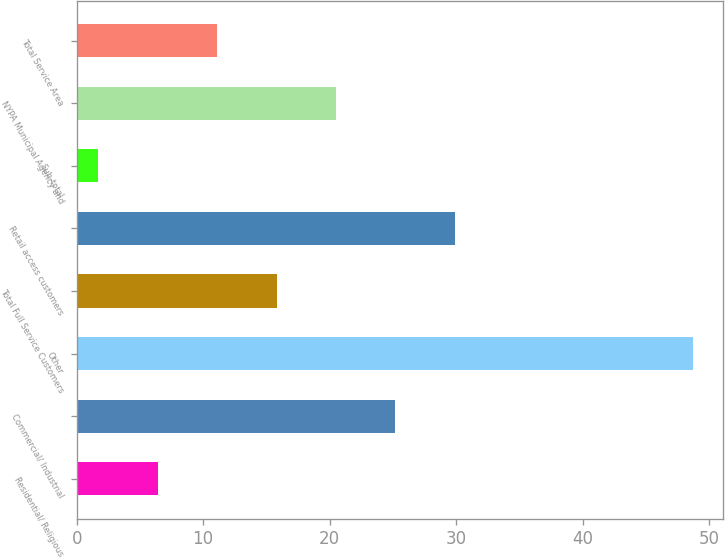Convert chart to OTSL. <chart><loc_0><loc_0><loc_500><loc_500><bar_chart><fcel>Residential/ Religious<fcel>Commercial/ Industrial<fcel>Other<fcel>Total Full Service Customers<fcel>Retail access customers<fcel>Sub-total<fcel>NYPA Municipal Agency and<fcel>Total Service Area<nl><fcel>6.4<fcel>25.2<fcel>48.7<fcel>15.8<fcel>29.9<fcel>1.7<fcel>20.5<fcel>11.1<nl></chart> 